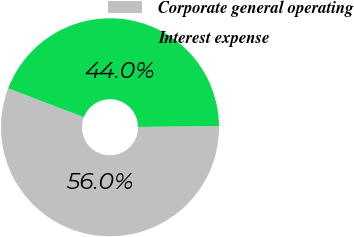Convert chart. <chart><loc_0><loc_0><loc_500><loc_500><pie_chart><fcel>Corporate general operating<fcel>Interest expense<nl><fcel>56.0%<fcel>44.0%<nl></chart> 